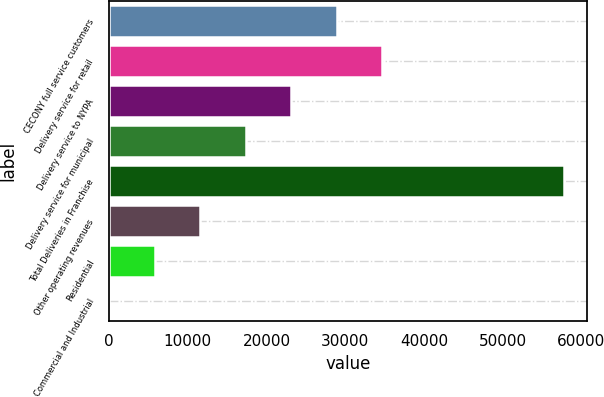Convert chart to OTSL. <chart><loc_0><loc_0><loc_500><loc_500><bar_chart><fcel>CECONY full service customers<fcel>Delivery service for retail<fcel>Delivery service to NYPA<fcel>Delivery service for municipal<fcel>Total Deliveries in Franchise<fcel>Other operating revenues<fcel>Residential<fcel>Commercial and Industrial<nl><fcel>28923.3<fcel>34703.9<fcel>23142.8<fcel>17362.3<fcel>57826<fcel>11581.8<fcel>5801.23<fcel>20.7<nl></chart> 